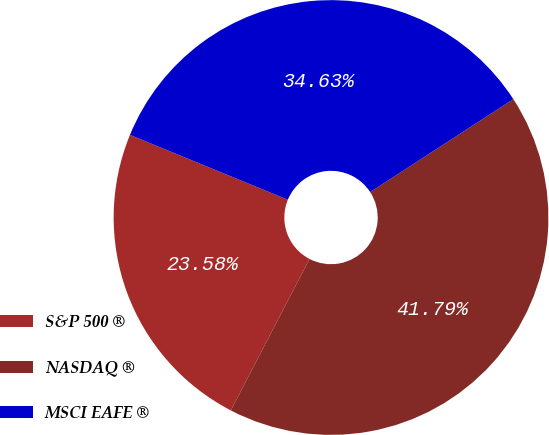Convert chart to OTSL. <chart><loc_0><loc_0><loc_500><loc_500><pie_chart><fcel>S&P 500 ®<fcel>NASDAQ ®<fcel>MSCI EAFE ®<nl><fcel>23.58%<fcel>41.79%<fcel>34.63%<nl></chart> 